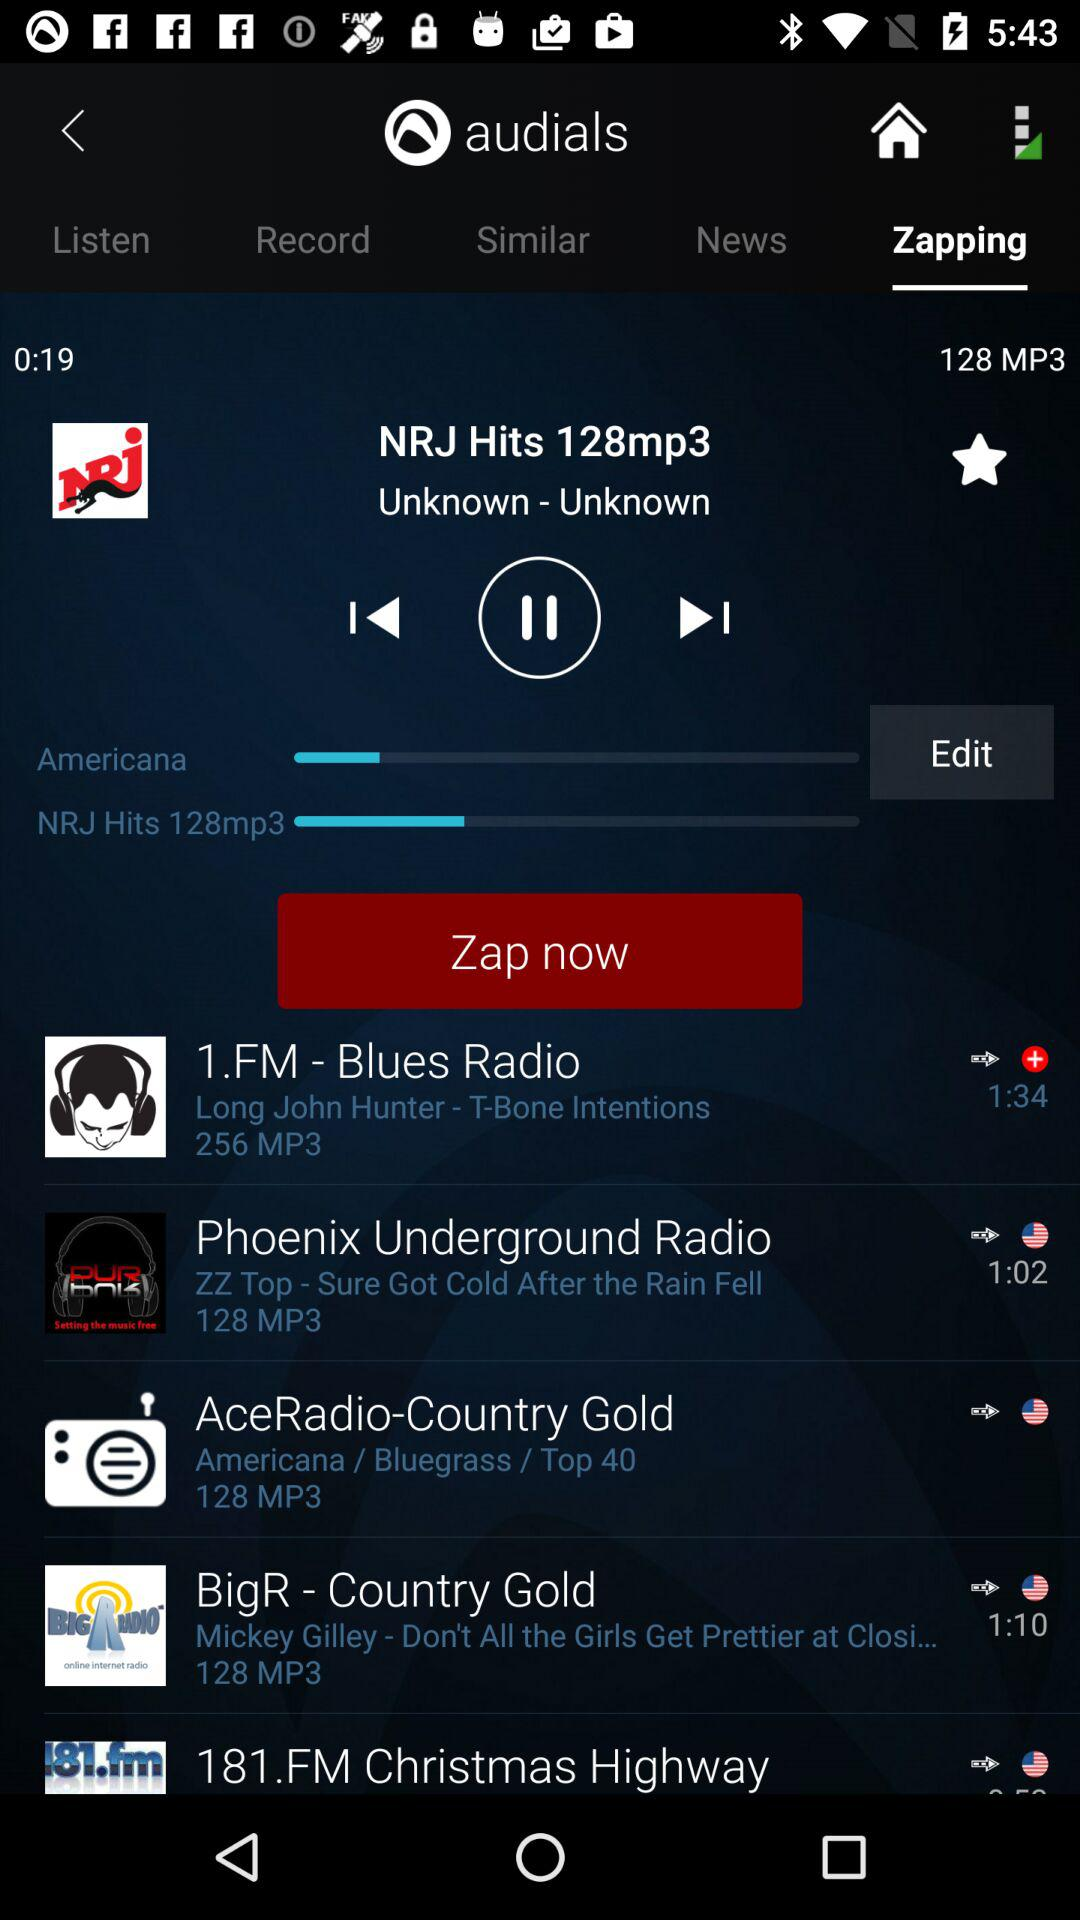Which song is playing? The song that is playing is "Americana". 